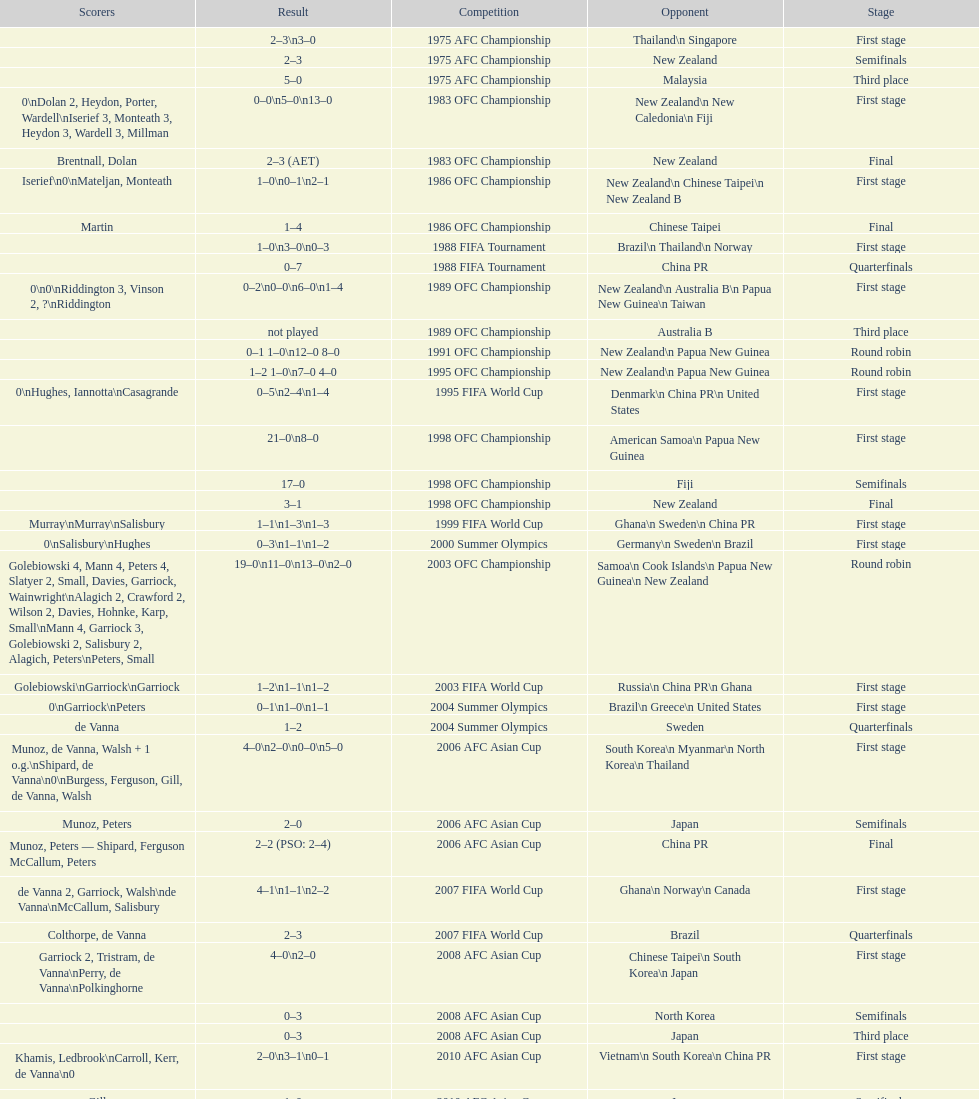What it the total number of countries in the first stage of the 2008 afc asian cup? 4. Would you be able to parse every entry in this table? {'header': ['Scorers', 'Result', 'Competition', 'Opponent', 'Stage'], 'rows': [['', '2–3\\n3–0', '1975 AFC Championship', 'Thailand\\n\xa0Singapore', 'First stage'], ['', '2–3', '1975 AFC Championship', 'New Zealand', 'Semifinals'], ['', '5–0', '1975 AFC Championship', 'Malaysia', 'Third place'], ['0\\nDolan 2, Heydon, Porter, Wardell\\nIserief 3, Monteath 3, Heydon 3, Wardell 3, Millman', '0–0\\n5–0\\n13–0', '1983 OFC Championship', 'New Zealand\\n\xa0New Caledonia\\n\xa0Fiji', 'First stage'], ['Brentnall, Dolan', '2–3 (AET)', '1983 OFC Championship', 'New Zealand', 'Final'], ['Iserief\\n0\\nMateljan, Monteath', '1–0\\n0–1\\n2–1', '1986 OFC Championship', 'New Zealand\\n\xa0Chinese Taipei\\n New Zealand B', 'First stage'], ['Martin', '1–4', '1986 OFC Championship', 'Chinese Taipei', 'Final'], ['', '1–0\\n3–0\\n0–3', '1988 FIFA Tournament', 'Brazil\\n\xa0Thailand\\n\xa0Norway', 'First stage'], ['', '0–7', '1988 FIFA Tournament', 'China PR', 'Quarterfinals'], ['0\\n0\\nRiddington 3, Vinson 2,\xa0?\\nRiddington', '0–2\\n0–0\\n6–0\\n1–4', '1989 OFC Championship', 'New Zealand\\n Australia B\\n\xa0Papua New Guinea\\n\xa0Taiwan', 'First stage'], ['', 'not played', '1989 OFC Championship', 'Australia B', 'Third place'], ['', '0–1 1–0\\n12–0 8–0', '1991 OFC Championship', 'New Zealand\\n\xa0Papua New Guinea', 'Round robin'], ['', '1–2 1–0\\n7–0 4–0', '1995 OFC Championship', 'New Zealand\\n\xa0Papua New Guinea', 'Round robin'], ['0\\nHughes, Iannotta\\nCasagrande', '0–5\\n2–4\\n1–4', '1995 FIFA World Cup', 'Denmark\\n\xa0China PR\\n\xa0United States', 'First stage'], ['', '21–0\\n8–0', '1998 OFC Championship', 'American Samoa\\n\xa0Papua New Guinea', 'First stage'], ['', '17–0', '1998 OFC Championship', 'Fiji', 'Semifinals'], ['', '3–1', '1998 OFC Championship', 'New Zealand', 'Final'], ['Murray\\nMurray\\nSalisbury', '1–1\\n1–3\\n1–3', '1999 FIFA World Cup', 'Ghana\\n\xa0Sweden\\n\xa0China PR', 'First stage'], ['0\\nSalisbury\\nHughes', '0–3\\n1–1\\n1–2', '2000 Summer Olympics', 'Germany\\n\xa0Sweden\\n\xa0Brazil', 'First stage'], ['Golebiowski 4, Mann 4, Peters 4, Slatyer 2, Small, Davies, Garriock, Wainwright\\nAlagich 2, Crawford 2, Wilson 2, Davies, Hohnke, Karp, Small\\nMann 4, Garriock 3, Golebiowski 2, Salisbury 2, Alagich, Peters\\nPeters, Small', '19–0\\n11–0\\n13–0\\n2–0', '2003 OFC Championship', 'Samoa\\n\xa0Cook Islands\\n\xa0Papua New Guinea\\n\xa0New Zealand', 'Round robin'], ['Golebiowski\\nGarriock\\nGarriock', '1–2\\n1–1\\n1–2', '2003 FIFA World Cup', 'Russia\\n\xa0China PR\\n\xa0Ghana', 'First stage'], ['0\\nGarriock\\nPeters', '0–1\\n1–0\\n1–1', '2004 Summer Olympics', 'Brazil\\n\xa0Greece\\n\xa0United States', 'First stage'], ['de Vanna', '1–2', '2004 Summer Olympics', 'Sweden', 'Quarterfinals'], ['Munoz, de Vanna, Walsh + 1 o.g.\\nShipard, de Vanna\\n0\\nBurgess, Ferguson, Gill, de Vanna, Walsh', '4–0\\n2–0\\n0–0\\n5–0', '2006 AFC Asian Cup', 'South Korea\\n\xa0Myanmar\\n\xa0North Korea\\n\xa0Thailand', 'First stage'], ['Munoz, Peters', '2–0', '2006 AFC Asian Cup', 'Japan', 'Semifinals'], ['Munoz, Peters — Shipard, Ferguson McCallum, Peters', '2–2 (PSO: 2–4)', '2006 AFC Asian Cup', 'China PR', 'Final'], ['de Vanna 2, Garriock, Walsh\\nde Vanna\\nMcCallum, Salisbury', '4–1\\n1–1\\n2–2', '2007 FIFA World Cup', 'Ghana\\n\xa0Norway\\n\xa0Canada', 'First stage'], ['Colthorpe, de Vanna', '2–3', '2007 FIFA World Cup', 'Brazil', 'Quarterfinals'], ['Garriock 2, Tristram, de Vanna\\nPerry, de Vanna\\nPolkinghorne', '4–0\\n2–0', '2008 AFC Asian Cup', 'Chinese Taipei\\n\xa0South Korea\\n\xa0Japan', 'First stage'], ['', '0–3', '2008 AFC Asian Cup', 'North Korea', 'Semifinals'], ['', '0–3', '2008 AFC Asian Cup', 'Japan', 'Third place'], ['Khamis, Ledbrook\\nCarroll, Kerr, de Vanna\\n0', '2–0\\n3–1\\n0–1', '2010 AFC Asian Cup', 'Vietnam\\n\xa0South Korea\\n\xa0China PR', 'First stage'], ['Gill', '1–0', '2010 AFC Asian Cup', 'Japan', 'Semifinals'], ['Kerr — PSO: Shipard, Ledbrook, Gill, Garriock, Simon', '1–1 (PSO: 5–4)', '2010 AFC Asian Cup', 'North Korea', 'Final'], ['0\\nvan Egmond, Khamis, de Vanna\\nSimon 2', '0–1\\n3–2\\n2–1', '2011 FIFA World Cup', 'Brazil\\n\xa0Equatorial Guinea\\n\xa0Norway', 'First stage'], ['Perry', '1–3', '2011 FIFA World Cup', 'Sweden', 'Quarterfinals'], ['0\\nHeyman 2, Butt, van Egmond, Simon\\n0\\nvan Egmond\\nButt, de Vanna', '0–1\\n5–1\\n0–1\\n1–0\\n2–1', '2012 Summer Olympics\\nAFC qualification', 'North Korea\\n\xa0Thailand\\n\xa0Japan\\n\xa0China PR\\n\xa0South Korea', 'Final round'], ['', 'TBD\\nTBD\\nTBD', '2014 AFC Asian Cup', 'Japan\\n\xa0Jordan\\n\xa0Vietnam', 'First stage']]} 